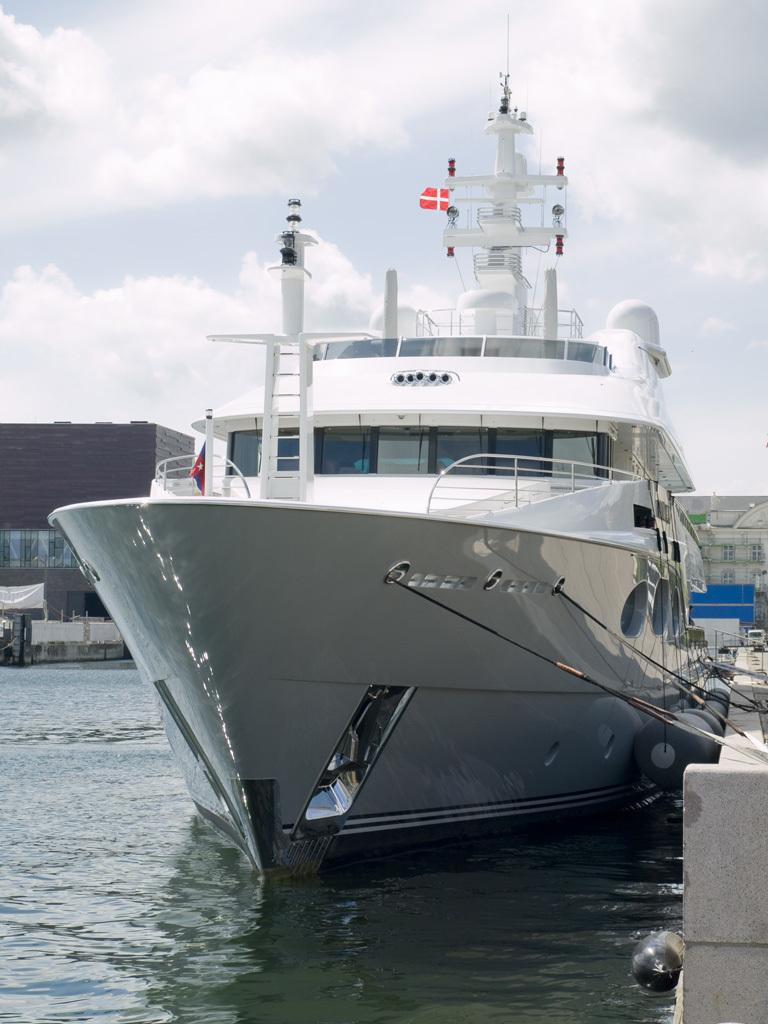What structure is located on the right side of the image? There is a dock on the right side of the image. What is the main subject in the middle of the image? There is a ship in the middle of the image. What are the ropes used for near the ship? The ropes are present near the ship, likely for tying or securing the ship. What type of environment is depicted at the bottom of the image? There is a water body at the bottom of the image. What can be seen in the background of the image? There are buildings in the background of the image. What is visible at the top of the image? The sky is visible at the top of the image. What type of arm is visible on the ship in the image? There is no arm visible on the ship in the image. What type of harmony is being played by the musicians in the image? There are no musicians or any indication of harmony in the image. 